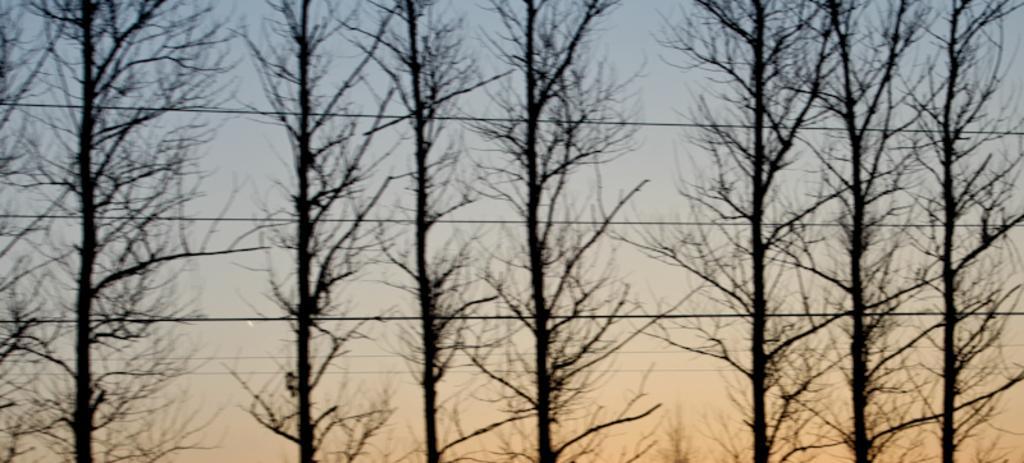How would you summarize this image in a sentence or two? In this image, we can see there are cables and trees. In the background, there are clouds in the blue sky. 